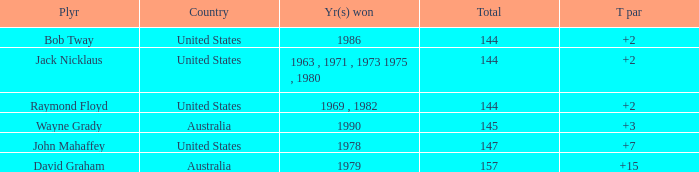How many strokes off par was the winner in 1978? 7.0. 